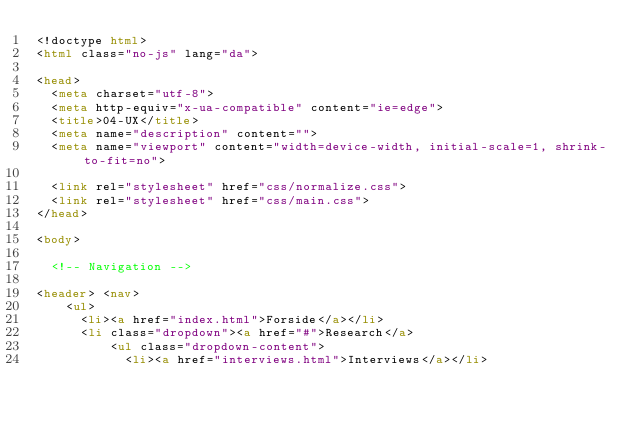Convert code to text. <code><loc_0><loc_0><loc_500><loc_500><_HTML_><!doctype html>
<html class="no-js" lang="da">

<head>
  <meta charset="utf-8">
  <meta http-equiv="x-ua-compatible" content="ie=edge">
  <title>04-UX</title>
  <meta name="description" content="">
  <meta name="viewport" content="width=device-width, initial-scale=1, shrink-to-fit=no">

  <link rel="stylesheet" href="css/normalize.css">
  <link rel="stylesheet" href="css/main.css">
</head>

<body>

  <!-- Navigation -->

<header> <nav>
    <ul>
      <li><a href="index.html">Forside</a></li>
      <li class="dropdown"><a href="#">Research</a>
          <ul class="dropdown-content">
            <li><a href="interviews.html">Interviews</a></li></code> 